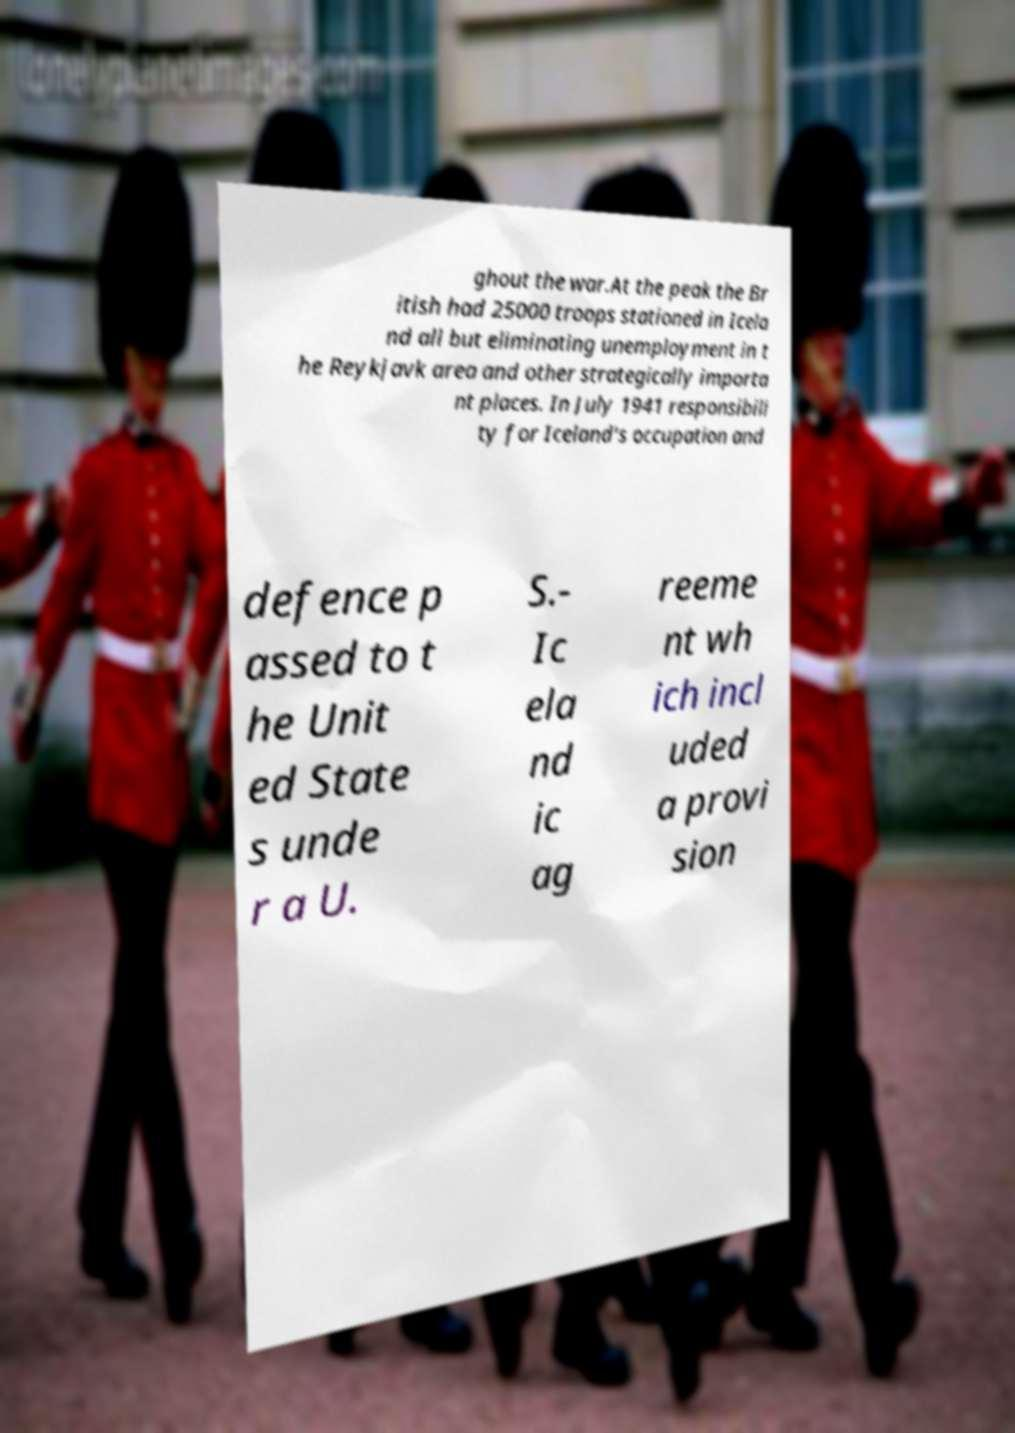Please read and relay the text visible in this image. What does it say? ghout the war.At the peak the Br itish had 25000 troops stationed in Icela nd all but eliminating unemployment in t he Reykjavk area and other strategically importa nt places. In July 1941 responsibili ty for Iceland's occupation and defence p assed to t he Unit ed State s unde r a U. S.- Ic ela nd ic ag reeme nt wh ich incl uded a provi sion 